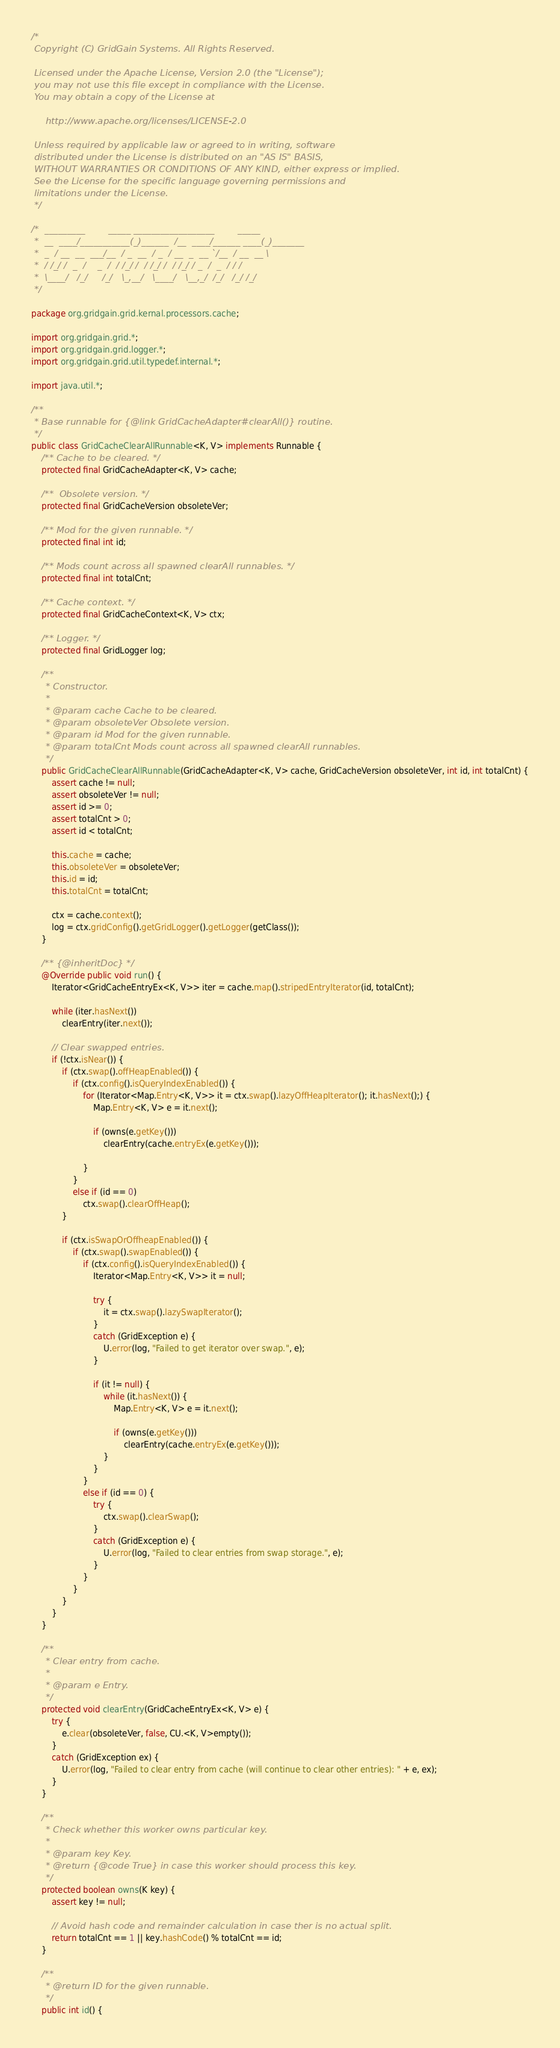Convert code to text. <code><loc_0><loc_0><loc_500><loc_500><_Java_>/* 
 Copyright (C) GridGain Systems. All Rights Reserved.
 
 Licensed under the Apache License, Version 2.0 (the "License");
 you may not use this file except in compliance with the License.
 You may obtain a copy of the License at

     http://www.apache.org/licenses/LICENSE-2.0
 
 Unless required by applicable law or agreed to in writing, software
 distributed under the License is distributed on an "AS IS" BASIS,
 WITHOUT WARRANTIES OR CONDITIONS OF ANY KIND, either express or implied.
 See the License for the specific language governing permissions and
 limitations under the License.
 */

/*  _________        _____ __________________        _____
 *  __  ____/___________(_)______  /__  ____/______ ____(_)_______
 *  _  / __  __  ___/__  / _  __  / _  / __  _  __ `/__  / __  __ \
 *  / /_/ /  _  /    _  /  / /_/ /  / /_/ /  / /_/ / _  /  _  / / /
 *  \____/   /_/     /_/   \_,__/   \____/   \__,_/  /_/   /_/ /_/
 */

package org.gridgain.grid.kernal.processors.cache;

import org.gridgain.grid.*;
import org.gridgain.grid.logger.*;
import org.gridgain.grid.util.typedef.internal.*;

import java.util.*;

/**
 * Base runnable for {@link GridCacheAdapter#clearAll()} routine.
 */
public class GridCacheClearAllRunnable<K, V> implements Runnable {
    /** Cache to be cleared. */
    protected final GridCacheAdapter<K, V> cache;

    /**  Obsolete version. */
    protected final GridCacheVersion obsoleteVer;

    /** Mod for the given runnable. */
    protected final int id;

    /** Mods count across all spawned clearAll runnables. */
    protected final int totalCnt;

    /** Cache context. */
    protected final GridCacheContext<K, V> ctx;

    /** Logger. */
    protected final GridLogger log;

    /**
     * Constructor.
     *
     * @param cache Cache to be cleared.
     * @param obsoleteVer Obsolete version.
     * @param id Mod for the given runnable.
     * @param totalCnt Mods count across all spawned clearAll runnables.
     */
    public GridCacheClearAllRunnable(GridCacheAdapter<K, V> cache, GridCacheVersion obsoleteVer, int id, int totalCnt) {
        assert cache != null;
        assert obsoleteVer != null;
        assert id >= 0;
        assert totalCnt > 0;
        assert id < totalCnt;

        this.cache = cache;
        this.obsoleteVer = obsoleteVer;
        this.id = id;
        this.totalCnt = totalCnt;

        ctx = cache.context();
        log = ctx.gridConfig().getGridLogger().getLogger(getClass());
    }

    /** {@inheritDoc} */
    @Override public void run() {
        Iterator<GridCacheEntryEx<K, V>> iter = cache.map().stripedEntryIterator(id, totalCnt);

        while (iter.hasNext())
            clearEntry(iter.next());

        // Clear swapped entries.
        if (!ctx.isNear()) {
            if (ctx.swap().offHeapEnabled()) {
                if (ctx.config().isQueryIndexEnabled()) {
                    for (Iterator<Map.Entry<K, V>> it = ctx.swap().lazyOffHeapIterator(); it.hasNext();) {
                        Map.Entry<K, V> e = it.next();

                        if (owns(e.getKey()))
                            clearEntry(cache.entryEx(e.getKey()));

                    }
                }
                else if (id == 0)
                    ctx.swap().clearOffHeap();
            }

            if (ctx.isSwapOrOffheapEnabled()) {
                if (ctx.swap().swapEnabled()) {
                    if (ctx.config().isQueryIndexEnabled()) {
                        Iterator<Map.Entry<K, V>> it = null;

                        try {
                            it = ctx.swap().lazySwapIterator();
                        }
                        catch (GridException e) {
                            U.error(log, "Failed to get iterator over swap.", e);
                        }

                        if (it != null) {
                            while (it.hasNext()) {
                                Map.Entry<K, V> e = it.next();

                                if (owns(e.getKey()))
                                    clearEntry(cache.entryEx(e.getKey()));
                            }
                        }
                    }
                    else if (id == 0) {
                        try {
                            ctx.swap().clearSwap();
                        }
                        catch (GridException e) {
                            U.error(log, "Failed to clear entries from swap storage.", e);
                        }
                    }
                }
            }
        }
    }

    /**
     * Clear entry from cache.
     *
     * @param e Entry.
     */
    protected void clearEntry(GridCacheEntryEx<K, V> e) {
        try {
            e.clear(obsoleteVer, false, CU.<K, V>empty());
        }
        catch (GridException ex) {
            U.error(log, "Failed to clear entry from cache (will continue to clear other entries): " + e, ex);
        }
    }

    /**
     * Check whether this worker owns particular key.
     *
     * @param key Key.
     * @return {@code True} in case this worker should process this key.
     */
    protected boolean owns(K key) {
        assert key != null;

        // Avoid hash code and remainder calculation in case ther is no actual split.
        return totalCnt == 1 || key.hashCode() % totalCnt == id;
    }

    /**
     * @return ID for the given runnable.
     */
    public int id() {</code> 